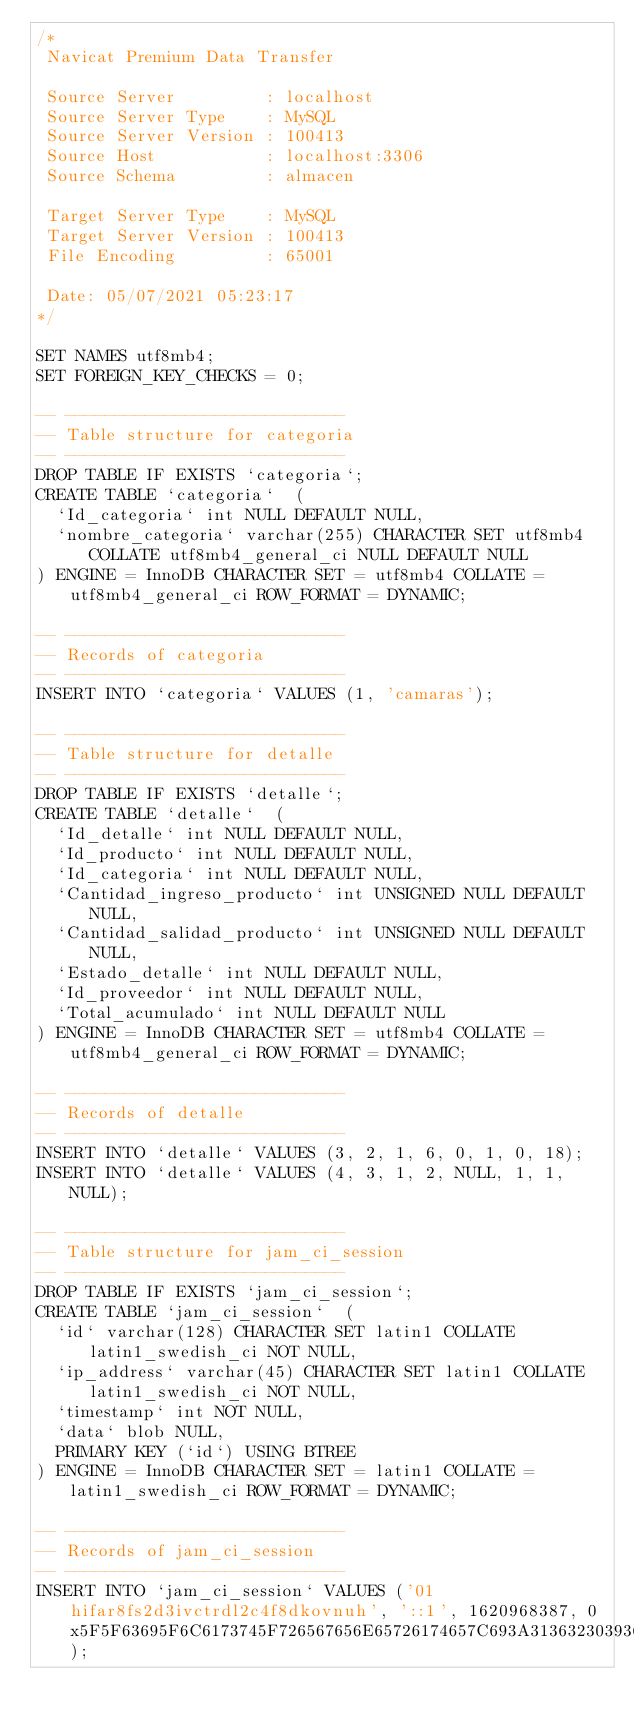<code> <loc_0><loc_0><loc_500><loc_500><_SQL_>/*
 Navicat Premium Data Transfer

 Source Server         : localhost
 Source Server Type    : MySQL
 Source Server Version : 100413
 Source Host           : localhost:3306
 Source Schema         : almacen

 Target Server Type    : MySQL
 Target Server Version : 100413
 File Encoding         : 65001

 Date: 05/07/2021 05:23:17
*/

SET NAMES utf8mb4;
SET FOREIGN_KEY_CHECKS = 0;

-- ----------------------------
-- Table structure for categoria
-- ----------------------------
DROP TABLE IF EXISTS `categoria`;
CREATE TABLE `categoria`  (
  `Id_categoria` int NULL DEFAULT NULL,
  `nombre_categoria` varchar(255) CHARACTER SET utf8mb4 COLLATE utf8mb4_general_ci NULL DEFAULT NULL
) ENGINE = InnoDB CHARACTER SET = utf8mb4 COLLATE = utf8mb4_general_ci ROW_FORMAT = DYNAMIC;

-- ----------------------------
-- Records of categoria
-- ----------------------------
INSERT INTO `categoria` VALUES (1, 'camaras');

-- ----------------------------
-- Table structure for detalle
-- ----------------------------
DROP TABLE IF EXISTS `detalle`;
CREATE TABLE `detalle`  (
  `Id_detalle` int NULL DEFAULT NULL,
  `Id_producto` int NULL DEFAULT NULL,
  `Id_categoria` int NULL DEFAULT NULL,
  `Cantidad_ingreso_producto` int UNSIGNED NULL DEFAULT NULL,
  `Cantidad_salidad_producto` int UNSIGNED NULL DEFAULT NULL,
  `Estado_detalle` int NULL DEFAULT NULL,
  `Id_proveedor` int NULL DEFAULT NULL,
  `Total_acumulado` int NULL DEFAULT NULL
) ENGINE = InnoDB CHARACTER SET = utf8mb4 COLLATE = utf8mb4_general_ci ROW_FORMAT = DYNAMIC;

-- ----------------------------
-- Records of detalle
-- ----------------------------
INSERT INTO `detalle` VALUES (3, 2, 1, 6, 0, 1, 0, 18);
INSERT INTO `detalle` VALUES (4, 3, 1, 2, NULL, 1, 1, NULL);

-- ----------------------------
-- Table structure for jam_ci_session
-- ----------------------------
DROP TABLE IF EXISTS `jam_ci_session`;
CREATE TABLE `jam_ci_session`  (
  `id` varchar(128) CHARACTER SET latin1 COLLATE latin1_swedish_ci NOT NULL,
  `ip_address` varchar(45) CHARACTER SET latin1 COLLATE latin1_swedish_ci NOT NULL,
  `timestamp` int NOT NULL,
  `data` blob NULL,
  PRIMARY KEY (`id`) USING BTREE
) ENGINE = InnoDB CHARACTER SET = latin1 COLLATE = latin1_swedish_ci ROW_FORMAT = DYNAMIC;

-- ----------------------------
-- Records of jam_ci_session
-- ----------------------------
INSERT INTO `jam_ci_session` VALUES ('01hifar8fs2d3ivctrdl2c4f8dkovnuh', '::1', 1620968387, 0x5F5F63695F6C6173745F726567656E65726174657C693A313632303936383338373B69735F6C6F677565645F696E5F61646D696E7C623A313B61646D5F69645F7573756172696F7C733A323A223139223B61646D5F656D61696C7C733A32333A22616C6F6E736F5F6261726F6E40686F746D61696C2E6573223B61646D5F70617373776F72647C4E3B61646D5F6E6F6D6272657C733A363A22416C6F6E736F223B61646D5F6170656C6C69646F7C733A353A224261726F6E223B61646D5F666F746F5F70657266696C7C4E3B);</code> 